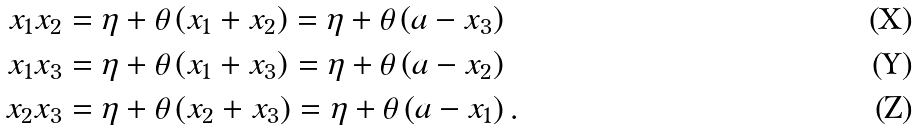<formula> <loc_0><loc_0><loc_500><loc_500>x _ { 1 } x _ { 2 } & = \eta + \theta \left ( x _ { 1 } + x _ { 2 } \right ) = \eta + \theta \left ( a - x _ { 3 } \right ) \\ x _ { 1 } x _ { 3 } & = \eta + \theta \left ( x _ { 1 } + x _ { 3 } \right ) = \eta + \theta \left ( a - x _ { 2 } \right ) \\ x _ { 2 } x _ { 3 } & = \eta + \theta \left ( x _ { 2 } + x _ { 3 } \right ) = \eta + \theta \left ( a - x _ { 1 } \right ) .</formula> 